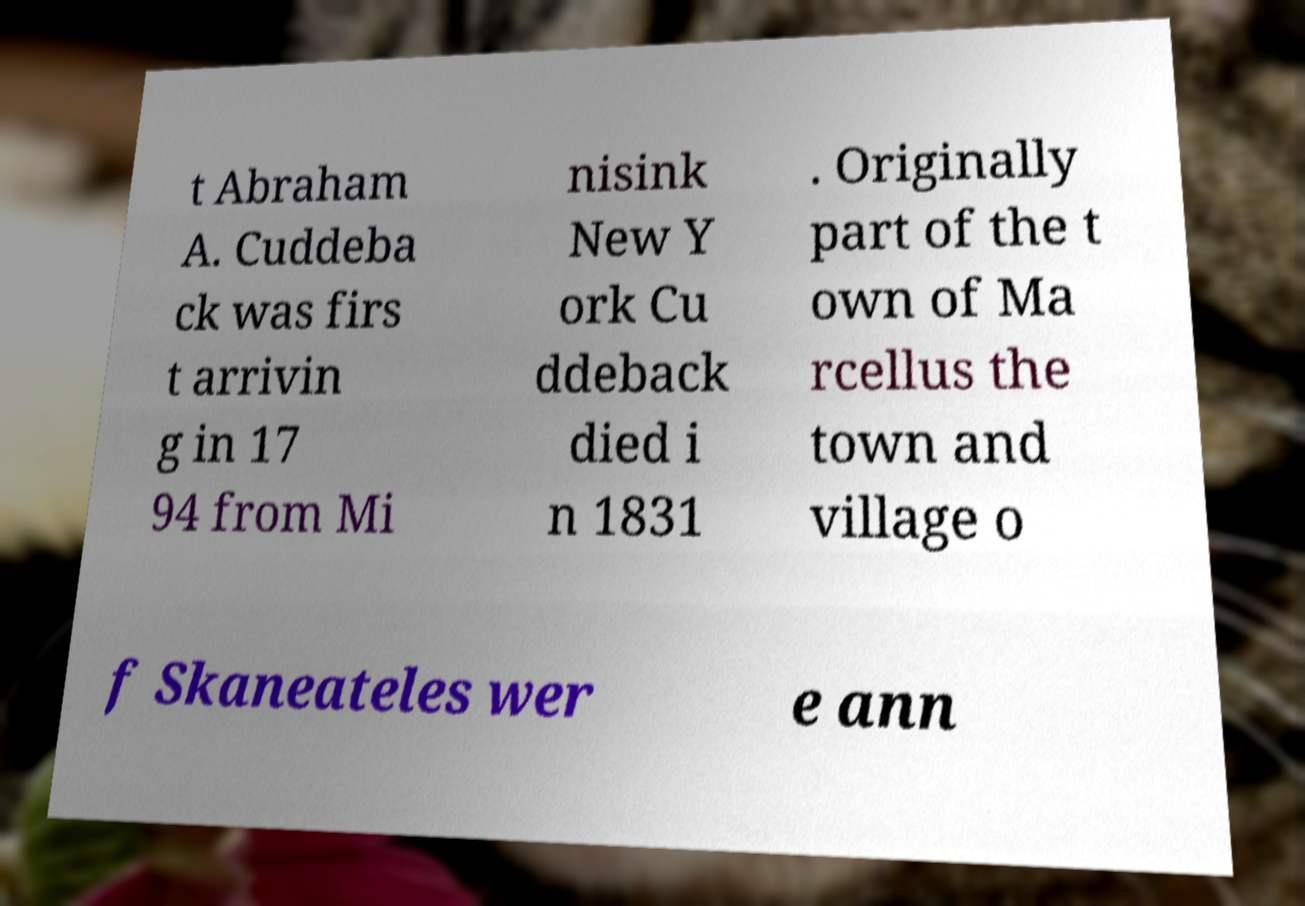Please identify and transcribe the text found in this image. t Abraham A. Cuddeba ck was firs t arrivin g in 17 94 from Mi nisink New Y ork Cu ddeback died i n 1831 . Originally part of the t own of Ma rcellus the town and village o f Skaneateles wer e ann 